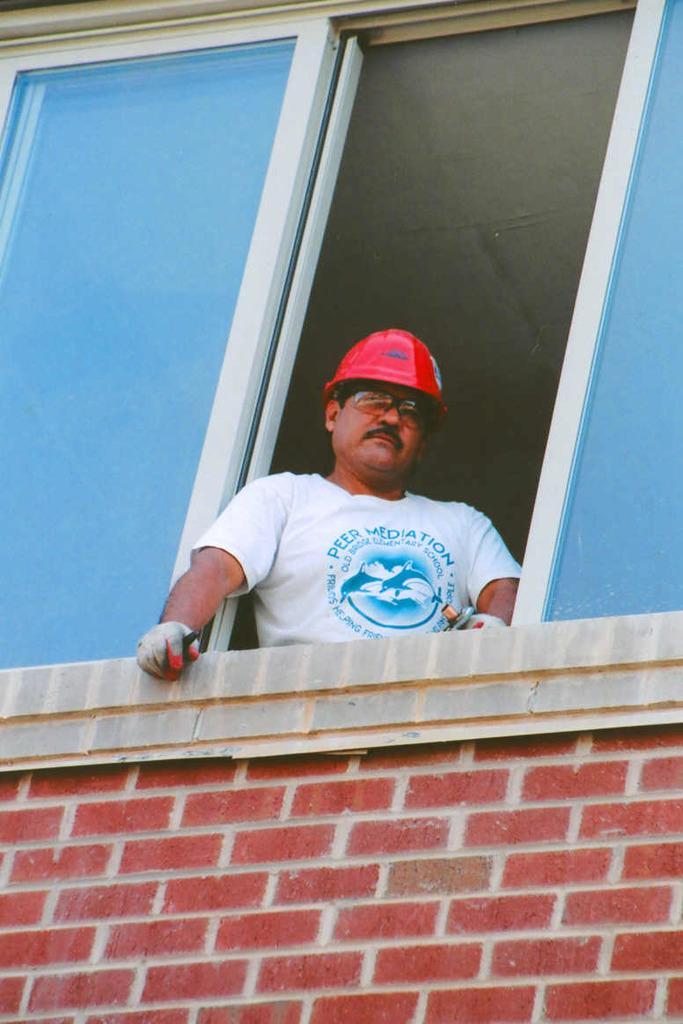Can you describe this image briefly? Here in this picture we can see a man peeping through a window present over a place and we can see he is wearing gloves, goggles and helmet on him. 